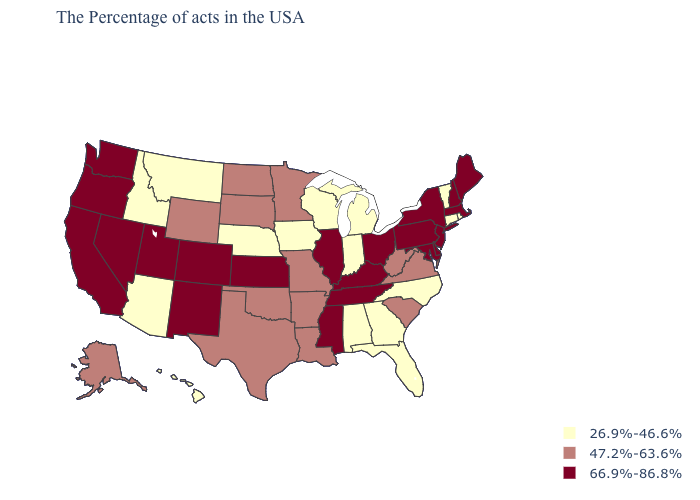What is the value of Georgia?
Write a very short answer. 26.9%-46.6%. What is the value of New Mexico?
Quick response, please. 66.9%-86.8%. Name the states that have a value in the range 47.2%-63.6%?
Write a very short answer. Virginia, South Carolina, West Virginia, Louisiana, Missouri, Arkansas, Minnesota, Oklahoma, Texas, South Dakota, North Dakota, Wyoming, Alaska. Name the states that have a value in the range 47.2%-63.6%?
Concise answer only. Virginia, South Carolina, West Virginia, Louisiana, Missouri, Arkansas, Minnesota, Oklahoma, Texas, South Dakota, North Dakota, Wyoming, Alaska. Which states have the highest value in the USA?
Write a very short answer. Maine, Massachusetts, New Hampshire, New York, New Jersey, Delaware, Maryland, Pennsylvania, Ohio, Kentucky, Tennessee, Illinois, Mississippi, Kansas, Colorado, New Mexico, Utah, Nevada, California, Washington, Oregon. Name the states that have a value in the range 66.9%-86.8%?
Short answer required. Maine, Massachusetts, New Hampshire, New York, New Jersey, Delaware, Maryland, Pennsylvania, Ohio, Kentucky, Tennessee, Illinois, Mississippi, Kansas, Colorado, New Mexico, Utah, Nevada, California, Washington, Oregon. Name the states that have a value in the range 66.9%-86.8%?
Write a very short answer. Maine, Massachusetts, New Hampshire, New York, New Jersey, Delaware, Maryland, Pennsylvania, Ohio, Kentucky, Tennessee, Illinois, Mississippi, Kansas, Colorado, New Mexico, Utah, Nevada, California, Washington, Oregon. Which states have the highest value in the USA?
Write a very short answer. Maine, Massachusetts, New Hampshire, New York, New Jersey, Delaware, Maryland, Pennsylvania, Ohio, Kentucky, Tennessee, Illinois, Mississippi, Kansas, Colorado, New Mexico, Utah, Nevada, California, Washington, Oregon. Which states have the lowest value in the South?
Give a very brief answer. North Carolina, Florida, Georgia, Alabama. Does Idaho have the same value as Ohio?
Short answer required. No. What is the lowest value in the South?
Quick response, please. 26.9%-46.6%. Name the states that have a value in the range 47.2%-63.6%?
Give a very brief answer. Virginia, South Carolina, West Virginia, Louisiana, Missouri, Arkansas, Minnesota, Oklahoma, Texas, South Dakota, North Dakota, Wyoming, Alaska. What is the lowest value in states that border Rhode Island?
Give a very brief answer. 26.9%-46.6%. Name the states that have a value in the range 47.2%-63.6%?
Short answer required. Virginia, South Carolina, West Virginia, Louisiana, Missouri, Arkansas, Minnesota, Oklahoma, Texas, South Dakota, North Dakota, Wyoming, Alaska. Among the states that border South Carolina , which have the lowest value?
Give a very brief answer. North Carolina, Georgia. 